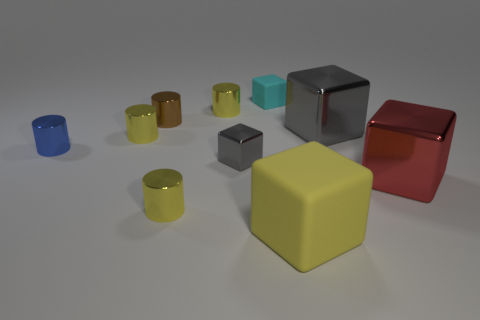Subtract all cyan cubes. How many yellow cylinders are left? 3 Subtract 1 cylinders. How many cylinders are left? 4 Subtract all red blocks. How many blocks are left? 4 Subtract all large yellow rubber blocks. How many blocks are left? 4 Subtract all green blocks. Subtract all gray spheres. How many blocks are left? 5 Subtract all large brown cylinders. Subtract all small metallic blocks. How many objects are left? 9 Add 4 small brown metallic things. How many small brown metallic things are left? 5 Add 6 matte objects. How many matte objects exist? 8 Subtract 0 cyan spheres. How many objects are left? 10 